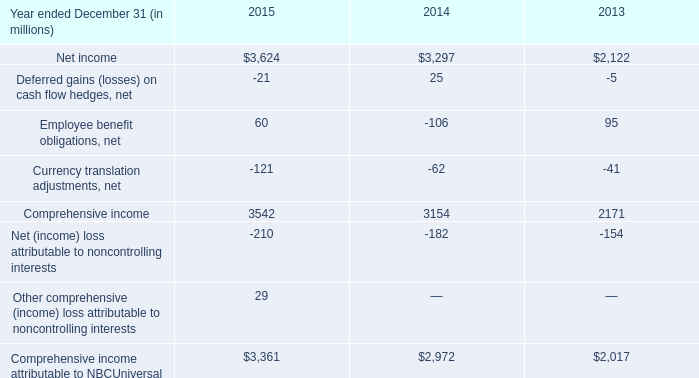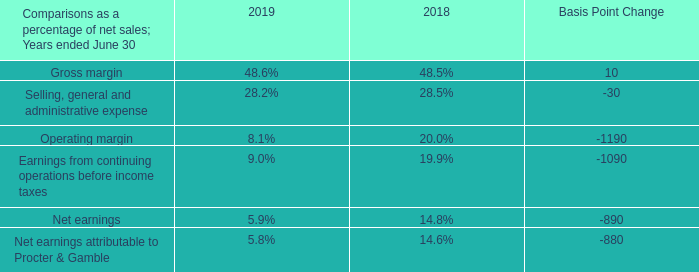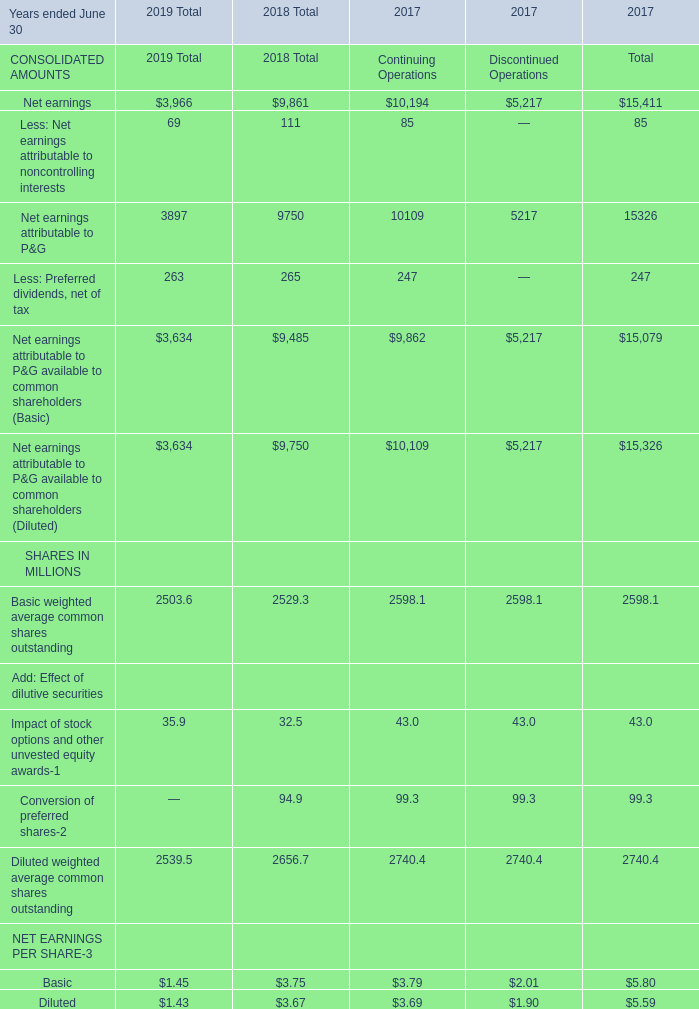Is the total amount of all elements in 2019 greater than that in 2018 ? 
Answer: no. 